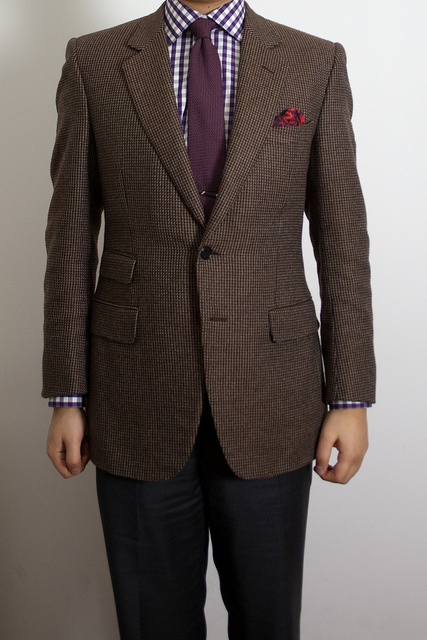Describe the objects in this image and their specific colors. I can see people in black, lightgray, gray, and maroon tones and tie in lightgray, purple, black, and gray tones in this image. 